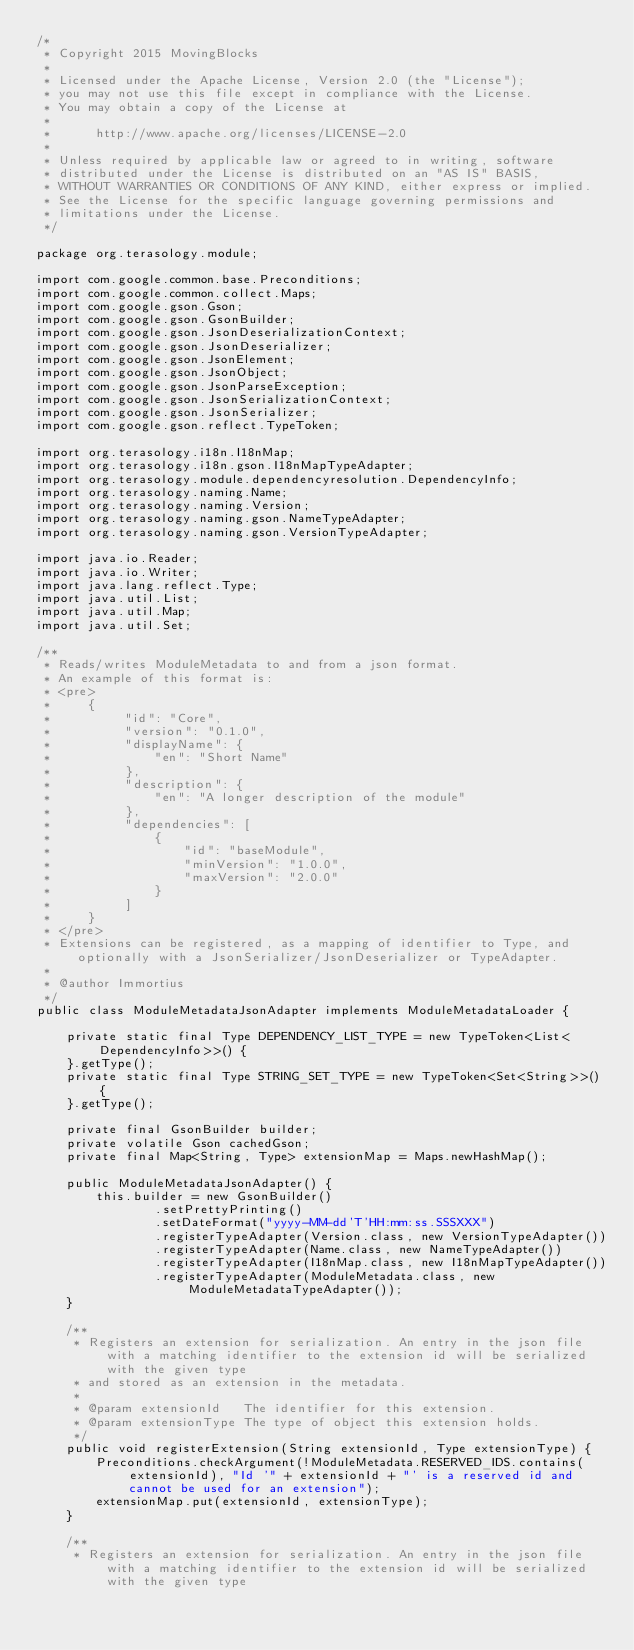Convert code to text. <code><loc_0><loc_0><loc_500><loc_500><_Java_>/*
 * Copyright 2015 MovingBlocks
 *
 * Licensed under the Apache License, Version 2.0 (the "License");
 * you may not use this file except in compliance with the License.
 * You may obtain a copy of the License at
 *
 *      http://www.apache.org/licenses/LICENSE-2.0
 *
 * Unless required by applicable law or agreed to in writing, software
 * distributed under the License is distributed on an "AS IS" BASIS,
 * WITHOUT WARRANTIES OR CONDITIONS OF ANY KIND, either express or implied.
 * See the License for the specific language governing permissions and
 * limitations under the License.
 */

package org.terasology.module;

import com.google.common.base.Preconditions;
import com.google.common.collect.Maps;
import com.google.gson.Gson;
import com.google.gson.GsonBuilder;
import com.google.gson.JsonDeserializationContext;
import com.google.gson.JsonDeserializer;
import com.google.gson.JsonElement;
import com.google.gson.JsonObject;
import com.google.gson.JsonParseException;
import com.google.gson.JsonSerializationContext;
import com.google.gson.JsonSerializer;
import com.google.gson.reflect.TypeToken;

import org.terasology.i18n.I18nMap;
import org.terasology.i18n.gson.I18nMapTypeAdapter;
import org.terasology.module.dependencyresolution.DependencyInfo;
import org.terasology.naming.Name;
import org.terasology.naming.Version;
import org.terasology.naming.gson.NameTypeAdapter;
import org.terasology.naming.gson.VersionTypeAdapter;

import java.io.Reader;
import java.io.Writer;
import java.lang.reflect.Type;
import java.util.List;
import java.util.Map;
import java.util.Set;

/**
 * Reads/writes ModuleMetadata to and from a json format.
 * An example of this format is:
 * <pre>
 *     {
 *          "id": "Core",
 *          "version": "0.1.0",
 *          "displayName": {
 *              "en": "Short Name"
 *          },
 *          "description": {
 *              "en": "A longer description of the module"
 *          },
 *          "dependencies": [
 *              {
 *                  "id": "baseModule",
 *                  "minVersion": "1.0.0",
 *                  "maxVersion": "2.0.0"
 *              }
 *          ]
 *     }
 * </pre>
 * Extensions can be registered, as a mapping of identifier to Type, and optionally with a JsonSerializer/JsonDeserializer or TypeAdapter.
 *
 * @author Immortius
 */
public class ModuleMetadataJsonAdapter implements ModuleMetadataLoader {

    private static final Type DEPENDENCY_LIST_TYPE = new TypeToken<List<DependencyInfo>>() {
    }.getType();
    private static final Type STRING_SET_TYPE = new TypeToken<Set<String>>() {
    }.getType();

    private final GsonBuilder builder;
    private volatile Gson cachedGson;
    private final Map<String, Type> extensionMap = Maps.newHashMap();

    public ModuleMetadataJsonAdapter() {
        this.builder = new GsonBuilder()
                .setPrettyPrinting()
                .setDateFormat("yyyy-MM-dd'T'HH:mm:ss.SSSXXX")
                .registerTypeAdapter(Version.class, new VersionTypeAdapter())
                .registerTypeAdapter(Name.class, new NameTypeAdapter())
                .registerTypeAdapter(I18nMap.class, new I18nMapTypeAdapter())
                .registerTypeAdapter(ModuleMetadata.class, new ModuleMetadataTypeAdapter());
    }

    /**
     * Registers an extension for serialization. An entry in the json file with a matching identifier to the extension id will be serialized with the given type
     * and stored as an extension in the metadata.
     *
     * @param extensionId   The identifier for this extension.
     * @param extensionType The type of object this extension holds.
     */
    public void registerExtension(String extensionId, Type extensionType) {
        Preconditions.checkArgument(!ModuleMetadata.RESERVED_IDS.contains(extensionId), "Id '" + extensionId + "' is a reserved id and cannot be used for an extension");
        extensionMap.put(extensionId, extensionType);
    }

    /**
     * Registers an extension for serialization. An entry in the json file with a matching identifier to the extension id will be serialized with the given type</code> 